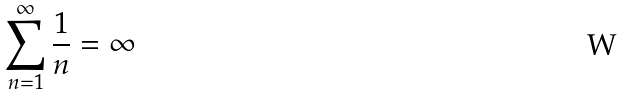<formula> <loc_0><loc_0><loc_500><loc_500>\sum _ { n = 1 } ^ { \infty } \frac { 1 } { n } = \infty</formula> 